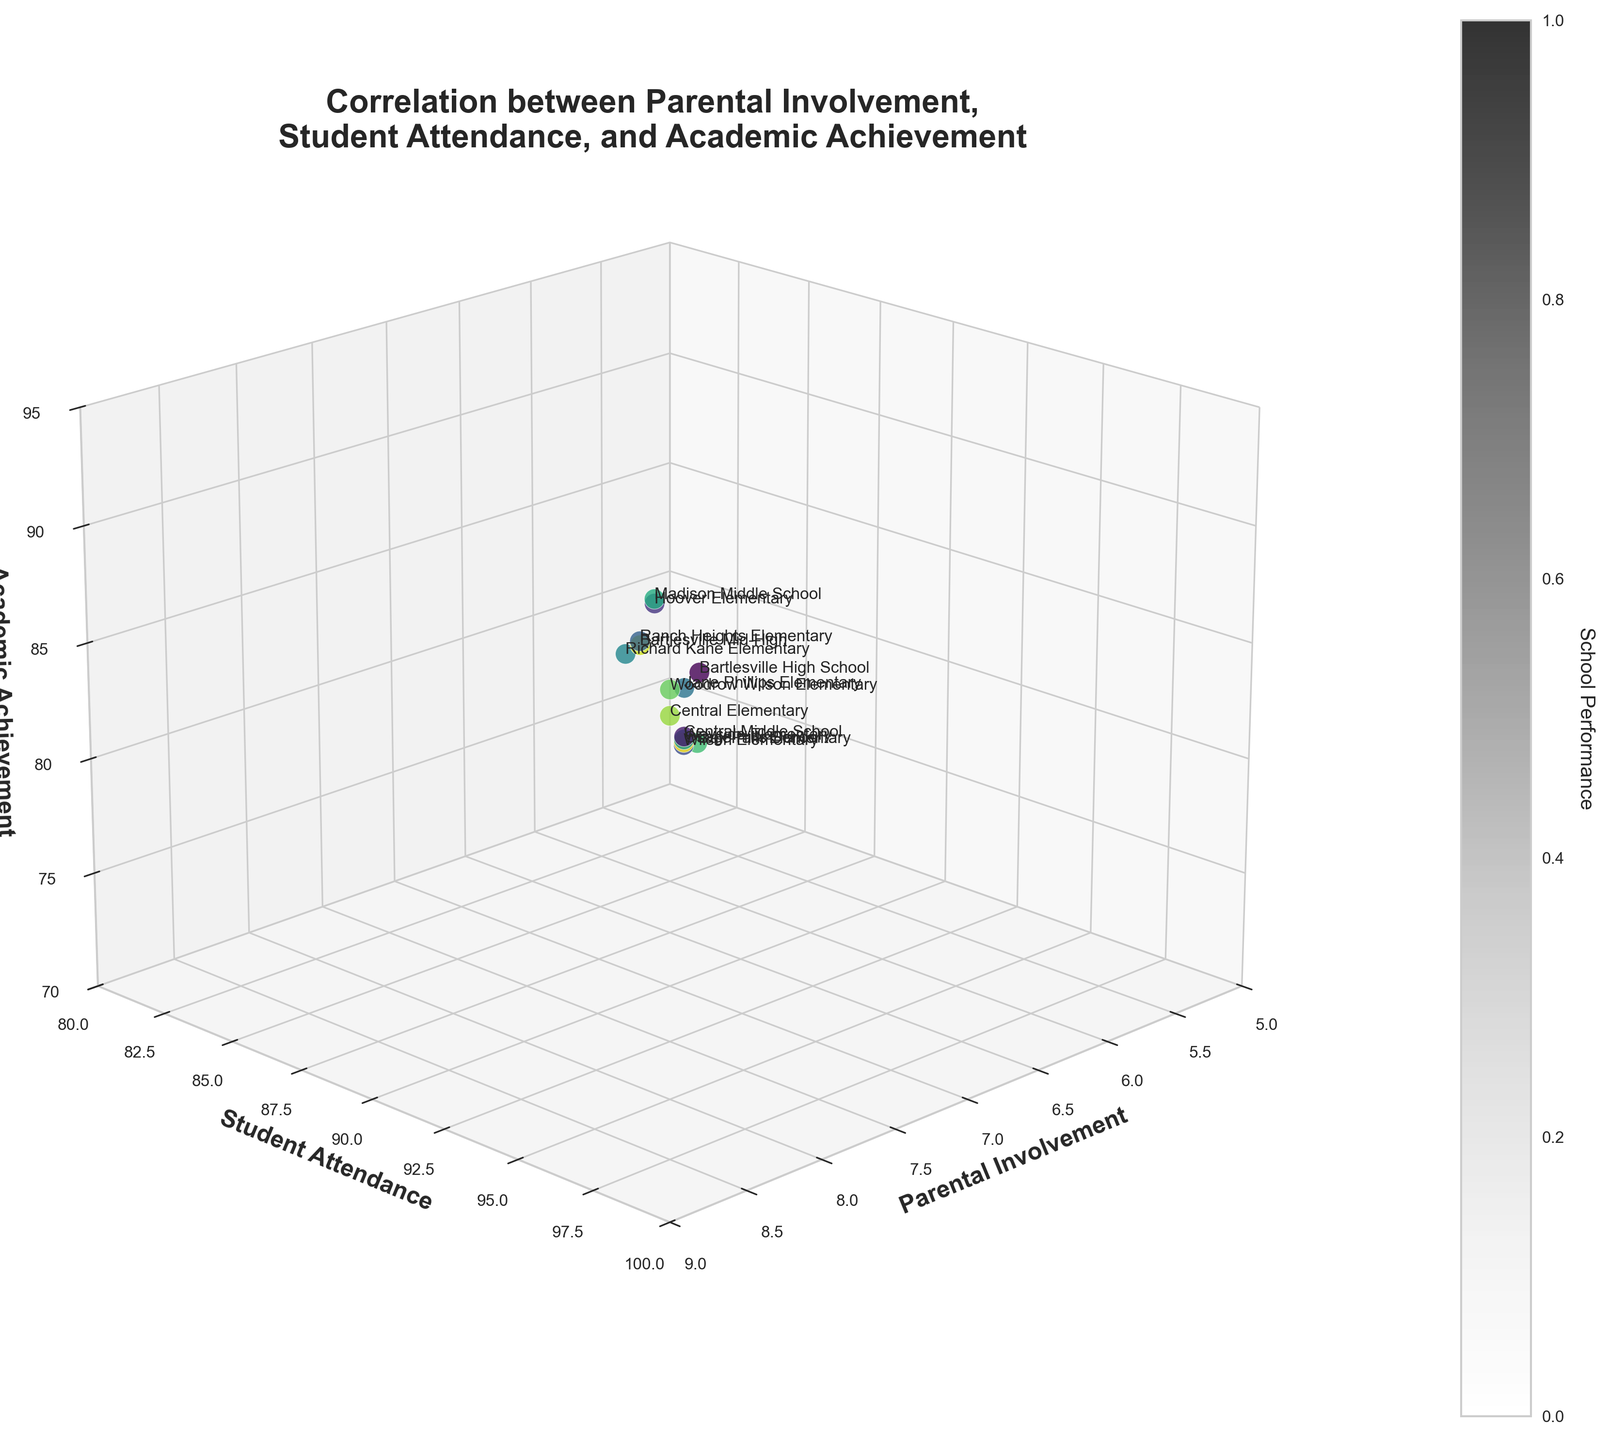Which school has the highest academic achievement score? By looking at the z-axis, identify the school with the highest academic achievement score. The highest point on the z-axis corresponds to Madison Middle School, with a score of 92.
Answer: Madison Middle School What is the title of the figure? The title is displayed at the top of the plot. It reads: "Correlation between Parental Involvement, Student Attendance, and Academic Achievement".
Answer: Correlation between Parental Involvement, Student Attendance, and Academic Achievement Across which ranges do the axes span? The x-axis, which represents Parental Involvement, ranges from 5 to 9. The y-axis, which represents Student Attendance, ranges from 80 to 100. The z-axis, which represents Academic Achievement, ranges from 70 to 95.
Answer: x: 5-9, y: 80-100, z: 70-95 Which school has the lowest parental involvement? By checking the lowest point along the x-axis, the school with the lowest parental involvement score is Oak Park Elementary with a score of 5.6.
Answer: Oak Park Elementary What is the average student attendance across the schools? To calculate this, add the student attendance values and divide by the number of schools. (92 + 88 + 95 + 85 + 93 + 89 + 91 + 87 + 96 + 84 + 90 + 89 + 92 + 86) / 14 = 90.36.
Answer: 90.36 Which school has the highest student attendance and how does its academic achievement compare? Look for the school with the highest y-axis value, which is Madison Middle School with an attendance of 96. Its academic achievement score is 92, the highest among all schools.
Answer: Madison Middle School; Academic Achievement: 92 How does parental involvement relate to academic achievement? Observe the overall trend of points in the plot. Generally, schools with higher parental involvement tend to also have higher academic achievement scores.
Answer: Higher involvement, higher achievement Is there any school with high student attendance but lower academic achievement? Look for schools with high values on the y-axis but lower values on the z-axis. Central Middle School has high student attendance (88) but relatively lower academic achievement (79).
Answer: Central Middle School Which school is positioned closest to the center point of all axes' ranges? Calculate the mid-point for each axis' range (x=7, y=90, z=82.5) and visually identify the school closest to these values. Woodrow Wilson Elementary (x=7, y=90, z=83) is closest.
Answer: Woodrow Wilson Elementary 